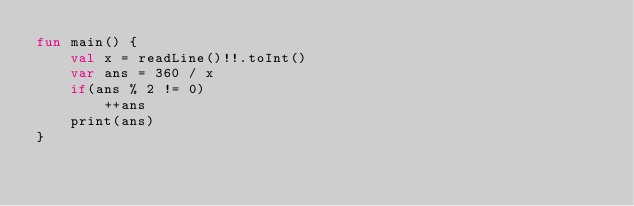Convert code to text. <code><loc_0><loc_0><loc_500><loc_500><_Kotlin_>fun main() {
    val x = readLine()!!.toInt()
    var ans = 360 / x
    if(ans % 2 != 0)
        ++ans
    print(ans)
}</code> 